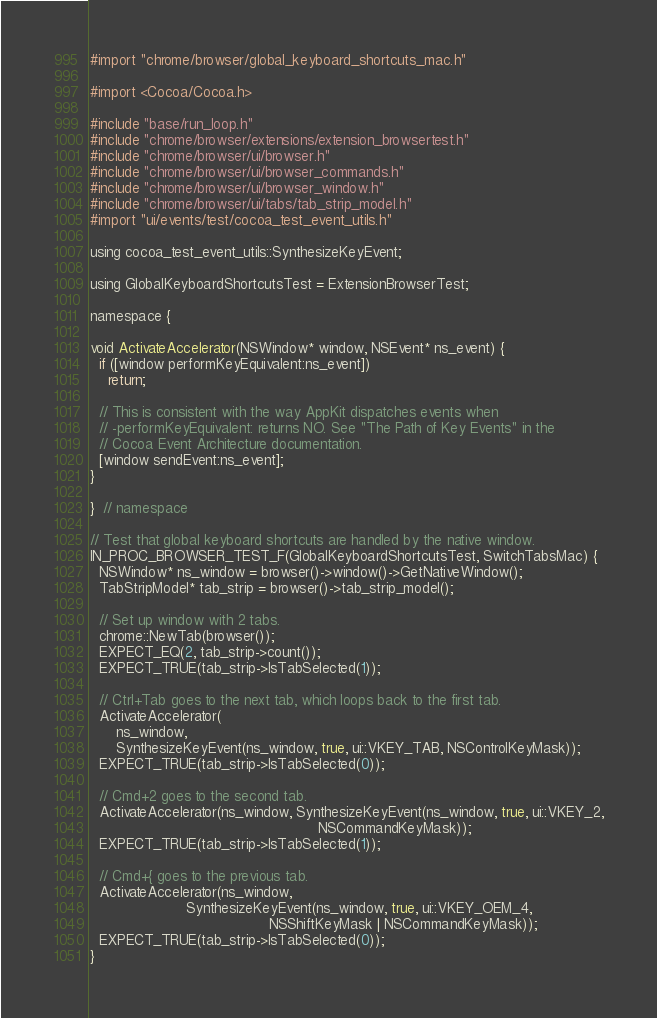Convert code to text. <code><loc_0><loc_0><loc_500><loc_500><_ObjectiveC_>#import "chrome/browser/global_keyboard_shortcuts_mac.h"

#import <Cocoa/Cocoa.h>

#include "base/run_loop.h"
#include "chrome/browser/extensions/extension_browsertest.h"
#include "chrome/browser/ui/browser.h"
#include "chrome/browser/ui/browser_commands.h"
#include "chrome/browser/ui/browser_window.h"
#include "chrome/browser/ui/tabs/tab_strip_model.h"
#import "ui/events/test/cocoa_test_event_utils.h"

using cocoa_test_event_utils::SynthesizeKeyEvent;

using GlobalKeyboardShortcutsTest = ExtensionBrowserTest;

namespace {

void ActivateAccelerator(NSWindow* window, NSEvent* ns_event) {
  if ([window performKeyEquivalent:ns_event])
    return;

  // This is consistent with the way AppKit dispatches events when
  // -performKeyEquivalent: returns NO. See "The Path of Key Events" in the
  // Cocoa Event Architecture documentation.
  [window sendEvent:ns_event];
}

}  // namespace

// Test that global keyboard shortcuts are handled by the native window.
IN_PROC_BROWSER_TEST_F(GlobalKeyboardShortcutsTest, SwitchTabsMac) {
  NSWindow* ns_window = browser()->window()->GetNativeWindow();
  TabStripModel* tab_strip = browser()->tab_strip_model();

  // Set up window with 2 tabs.
  chrome::NewTab(browser());
  EXPECT_EQ(2, tab_strip->count());
  EXPECT_TRUE(tab_strip->IsTabSelected(1));

  // Ctrl+Tab goes to the next tab, which loops back to the first tab.
  ActivateAccelerator(
      ns_window,
      SynthesizeKeyEvent(ns_window, true, ui::VKEY_TAB, NSControlKeyMask));
  EXPECT_TRUE(tab_strip->IsTabSelected(0));

  // Cmd+2 goes to the second tab.
  ActivateAccelerator(ns_window, SynthesizeKeyEvent(ns_window, true, ui::VKEY_2,
                                                    NSCommandKeyMask));
  EXPECT_TRUE(tab_strip->IsTabSelected(1));

  // Cmd+{ goes to the previous tab.
  ActivateAccelerator(ns_window,
                      SynthesizeKeyEvent(ns_window, true, ui::VKEY_OEM_4,
                                         NSShiftKeyMask | NSCommandKeyMask));
  EXPECT_TRUE(tab_strip->IsTabSelected(0));
}
</code> 